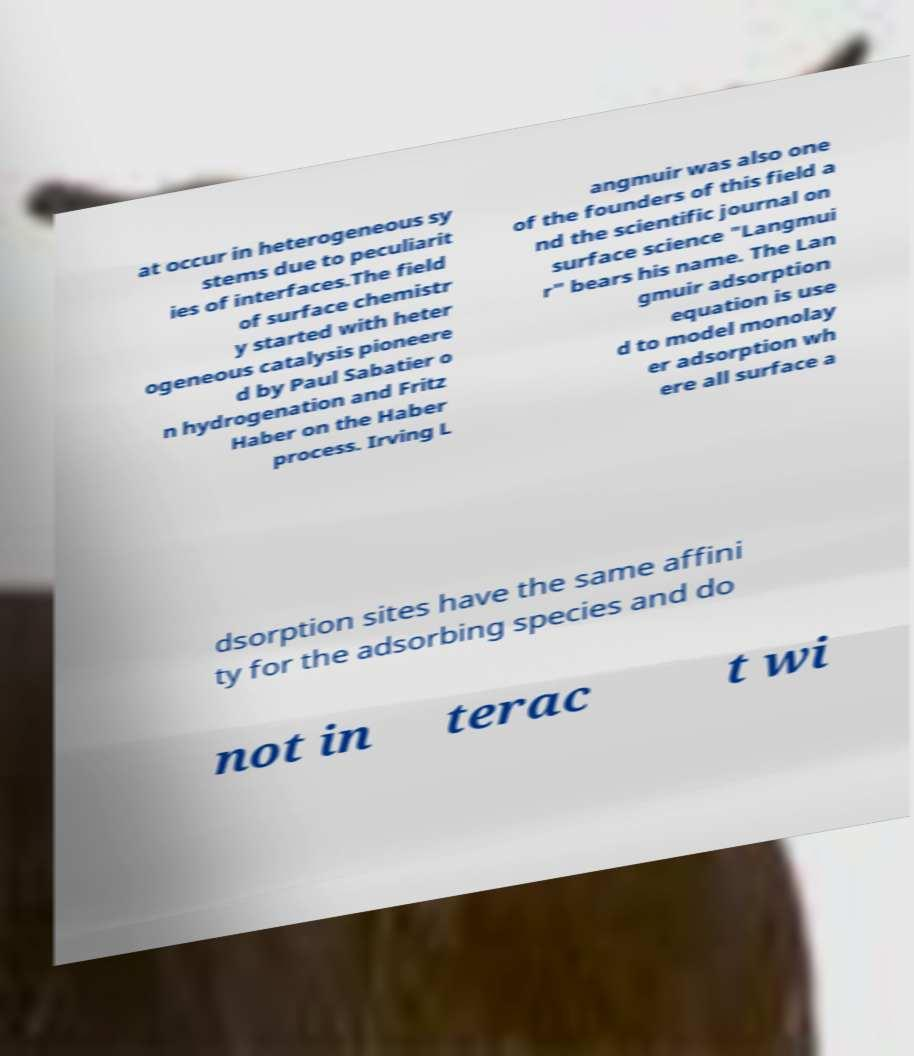Can you accurately transcribe the text from the provided image for me? at occur in heterogeneous sy stems due to peculiarit ies of interfaces.The field of surface chemistr y started with heter ogeneous catalysis pioneere d by Paul Sabatier o n hydrogenation and Fritz Haber on the Haber process. Irving L angmuir was also one of the founders of this field a nd the scientific journal on surface science "Langmui r" bears his name. The Lan gmuir adsorption equation is use d to model monolay er adsorption wh ere all surface a dsorption sites have the same affini ty for the adsorbing species and do not in terac t wi 